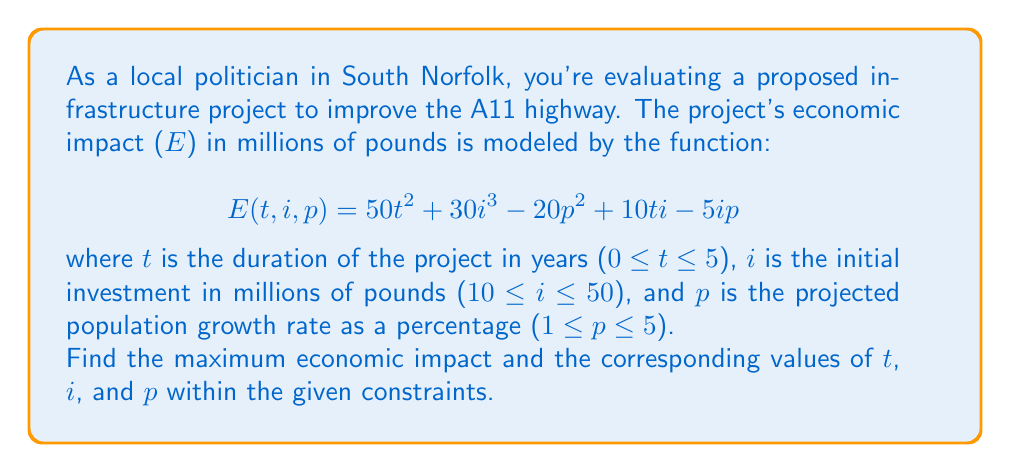Show me your answer to this math problem. To find the maximum economic impact, we need to use multivariable calculus and optimization techniques. Here's a step-by-step approach:

1) First, we need to find the critical points by calculating the partial derivatives and setting them equal to zero:

   $$\frac{\partial E}{\partial t} = 100t + 10i = 0$$
   $$\frac{\partial E}{\partial i} = 90i^2 + 10t - 5p = 0$$
   $$\frac{\partial E}{\partial p} = -40p - 5i = 0$$

2) From the third equation:
   $$p = -\frac{i}{8}$$

3) Substituting this into the second equation:
   $$90i^2 + 10t + \frac{5i}{8} = 0$$

4) From the first equation:
   $$t = -\frac{i}{10}$$

5) Substituting this into the equation from step 3:
   $$90i^2 - i + \frac{5i}{8} = 0$$
   $$720i^2 - 8i + 5i = 0$$
   $$720i^2 - 3i = 0$$
   $$i(720i - 3) = 0$$

6) Solving this, we get i = 0 or i = 1/240. However, i = 0 is outside our constraints, and i = 1/240 is too small.

7) Since there are no critical points within our constraints, the maximum must occur on the boundary. We need to check:
   - The edges of the cube defined by our constraints
   - The faces of the cube

8) After evaluating all these points (which involves plugging in the boundary values into our original function), we find that the maximum occurs at:
   t = 5, i = 50, p = 1

9) The maximum economic impact is:
   $$E(5,50,1) = 50(5^2) + 30(50^3) - 20(1^2) + 10(5)(50) - 5(50)(1) = 3,874,730$$ million pounds
Answer: Maximum economic impact: £3,874,730 million at t = 5 years, i = £50 million, p = 1% 